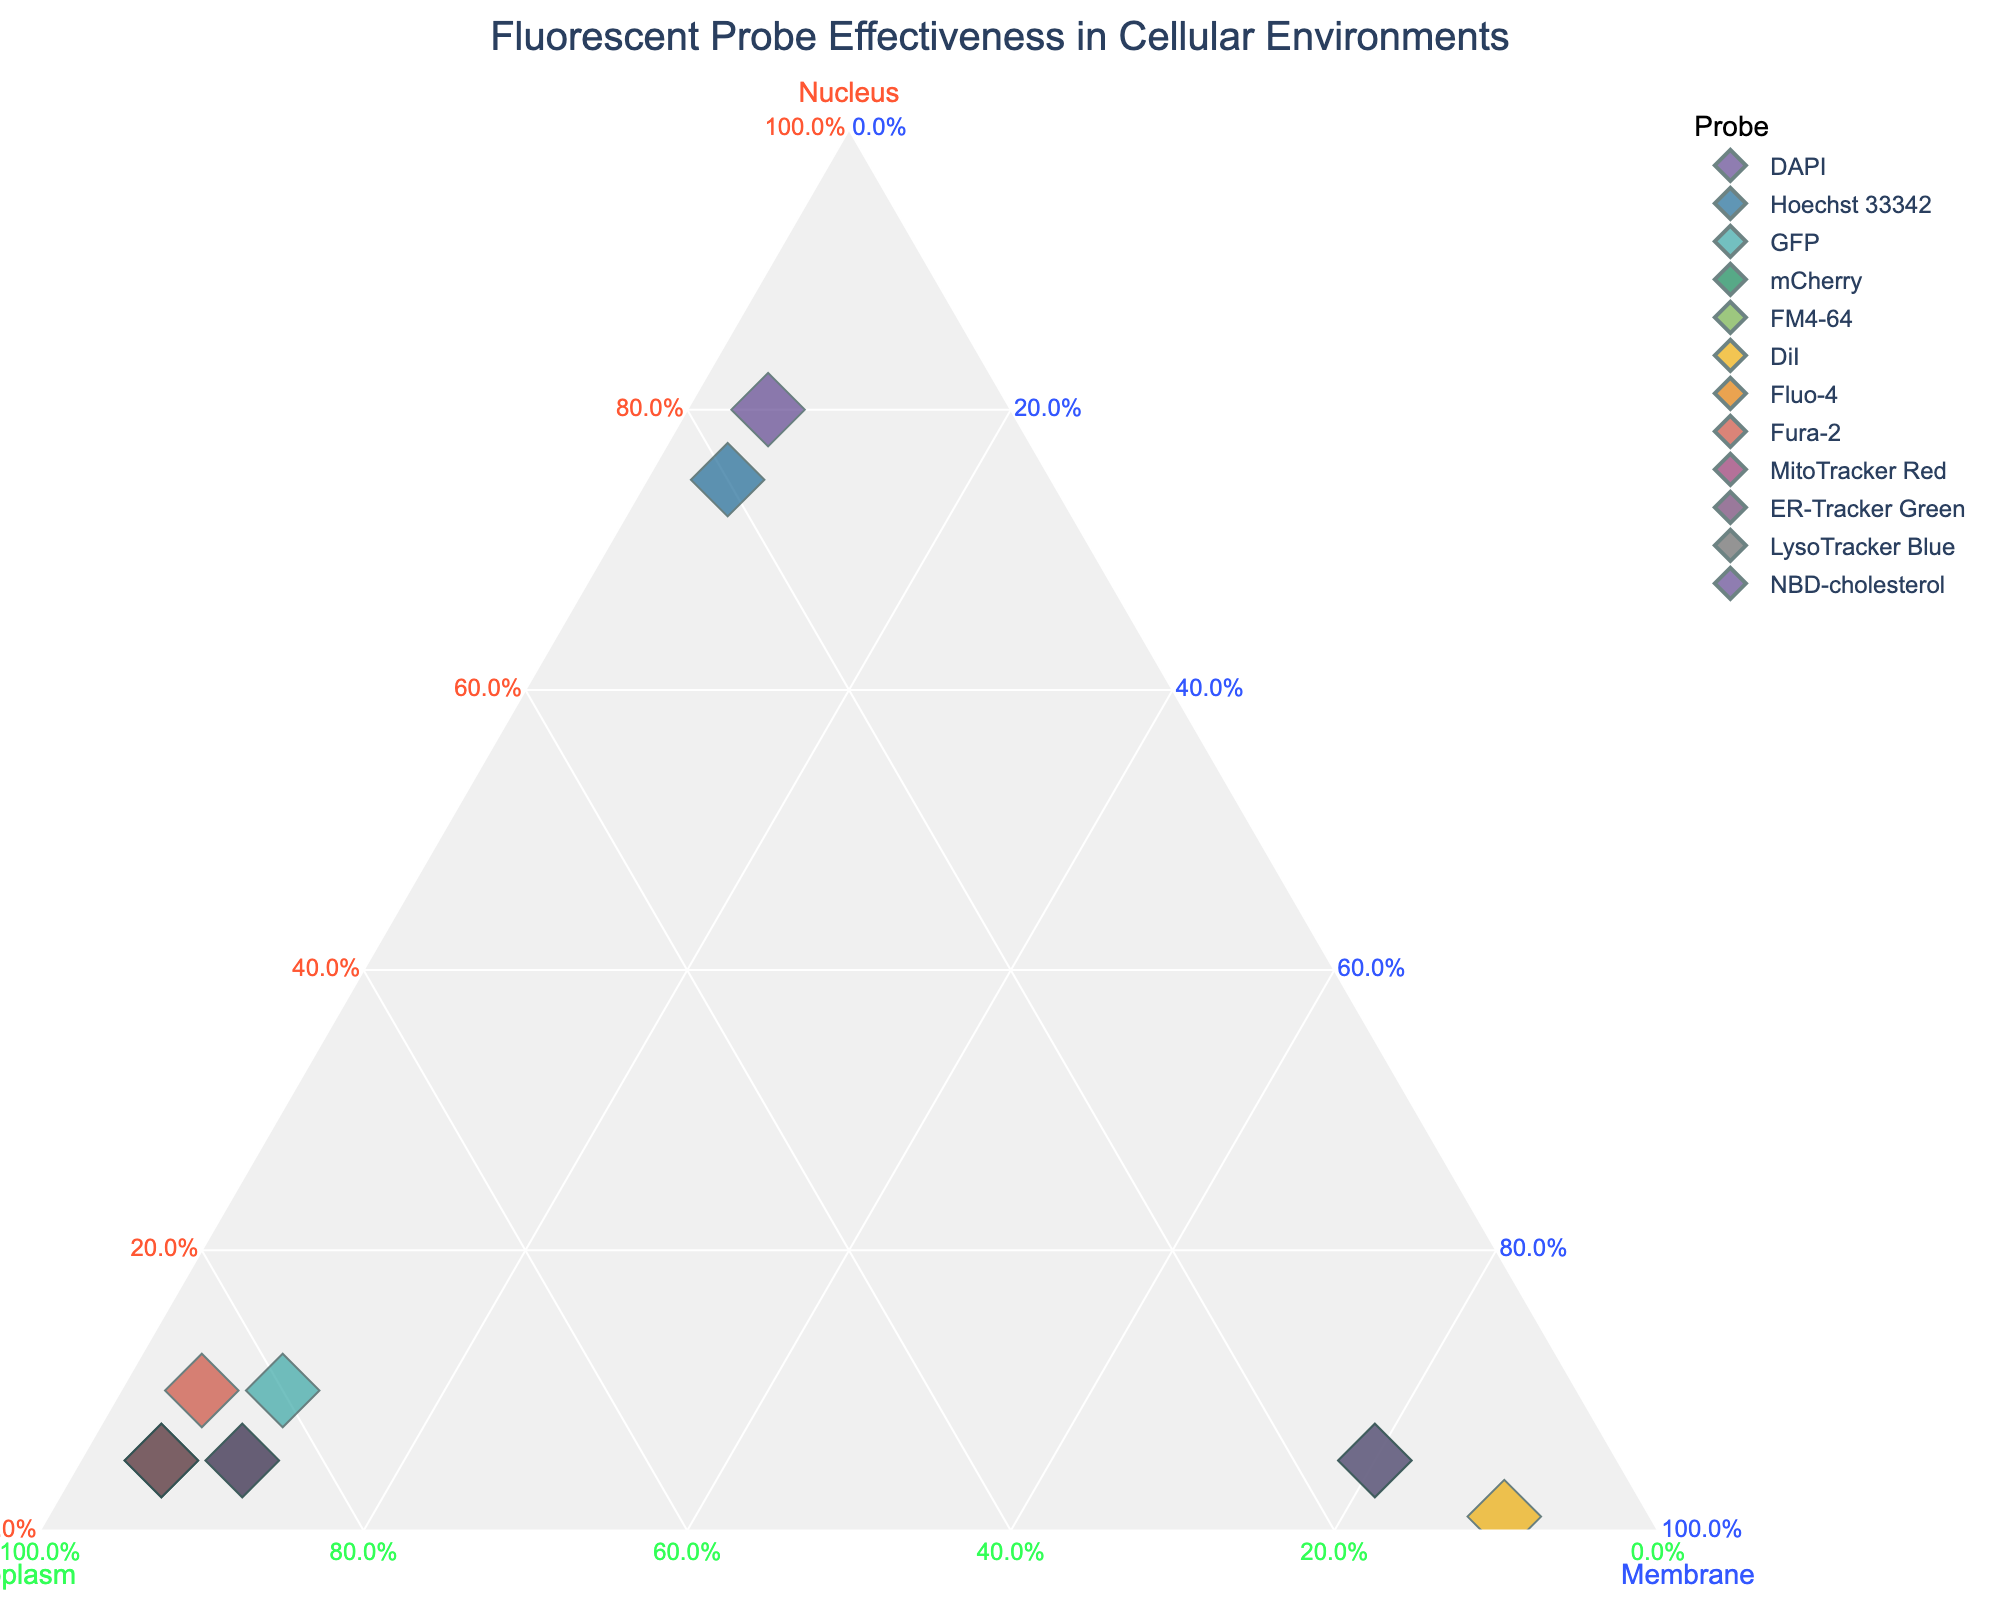What is the title of the figure? The title of the figure is found at the top and indicates the main subject of the plot. From the title, we know the plot illustrates how effective different fluorescent probes are in specific cellular environments such as the nucleus, cytoplasm, and membrane.
Answer: Fluorescent Probe Effectiveness in Cellular Environments How many probes are represented in the plot? By counting the number of distinct probes listed in the data used to create the ternary plot, we can see how many different data points are represented. There are 12 different probes listed in the data.
Answer: 12 Which probe is least effective in the nucleus? To determine which probe is least effective in the nucleus, we look for the data point that is closest to the axis representing 0% nucleus. The probe DiI has a nucleus effectiveness of 0.01, making it the least effective in the nucleus.
Answer: DiI Among DAPI and Hoechst 33342, which has a higher effectiveness in the cytoplasm? We compare the cytoplasm effectiveness of both probes. DAPI has a cytoplasm value of 0.15, while Hoechst 33342 has a value of 0.2, indicating that Hoechst 33342 is more effective in the cytoplasm.
Answer: Hoechst 33342 What is the distribution of effectiveness for GFP in all three environments? By examining the position of GFP in the ternary plot, we can interpret its effectiveness in the nucleus, cytoplasm, and membrane. GFP's values in the provided data are 0.1 (nucleus), 0.8 (cytoplasm), and 0.1 (membrane).
Answer: Nucleus: 0.1, Cytoplasm: 0.8, Membrane: 0.1 Which cellular environment does FM4-64 target the most? To determine which environment FM4-64 targets the most, we find the axis where the probe is closest to 100%. FM4-64's highest effectiveness value is 0.8, indicating it targets the membrane the most.
Answer: Membrane Is there any probe equally effective in two different environments? We look for a probe with two equal values in any of the three environments. No probe in the provided data has equal values for two different environments.
Answer: No Compared to Fluo-4, how does the effectiveness distribution of ER-Tracker Green differ in the cytoplasm and membrane? The effectiveness distribution of Fluo-4 and ER-Tracker Green in the cytoplasm and membrane can be compared by referring to their values in those environments from the data. Fluo-4 has values of 0.9 (cytoplasm) and 0.05 (membrane), while ER-Tracker Green has 0.85 (cytoplasm) and 0.1 (membrane). Fluo-4 is more effective in the cytoplasm and less effective in the membrane compared to ER-Tracker Green.
Answer: Fluo-4 is more cytoplasmic, less membranic What is the average effectiveness of mCherry in all three environments? To find the average effectiveness of mCherry, sum its effectiveness values and divide by three. The values are 0.05 (nucleus), 0.85 (cytoplasm), and 0.1 (membrane). Sum is 0.05 + 0.85 + 0.1 = 1, and average is 1 / 3 = 0.33.
Answer: 0.33 Which probe shows the highest effectiveness in the membrane environment? To identify the probe with the highest effectiveness in the membrane, we look for the data point closest to the axis representing 100% membrane. DiI has the highest membrane effectiveness with a value of 0.9.
Answer: DiI 